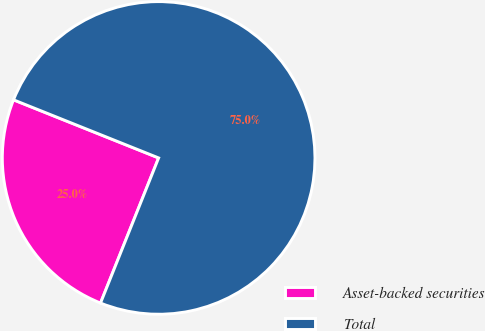<chart> <loc_0><loc_0><loc_500><loc_500><pie_chart><fcel>Asset-backed securities<fcel>Total<nl><fcel>25.0%<fcel>75.0%<nl></chart> 